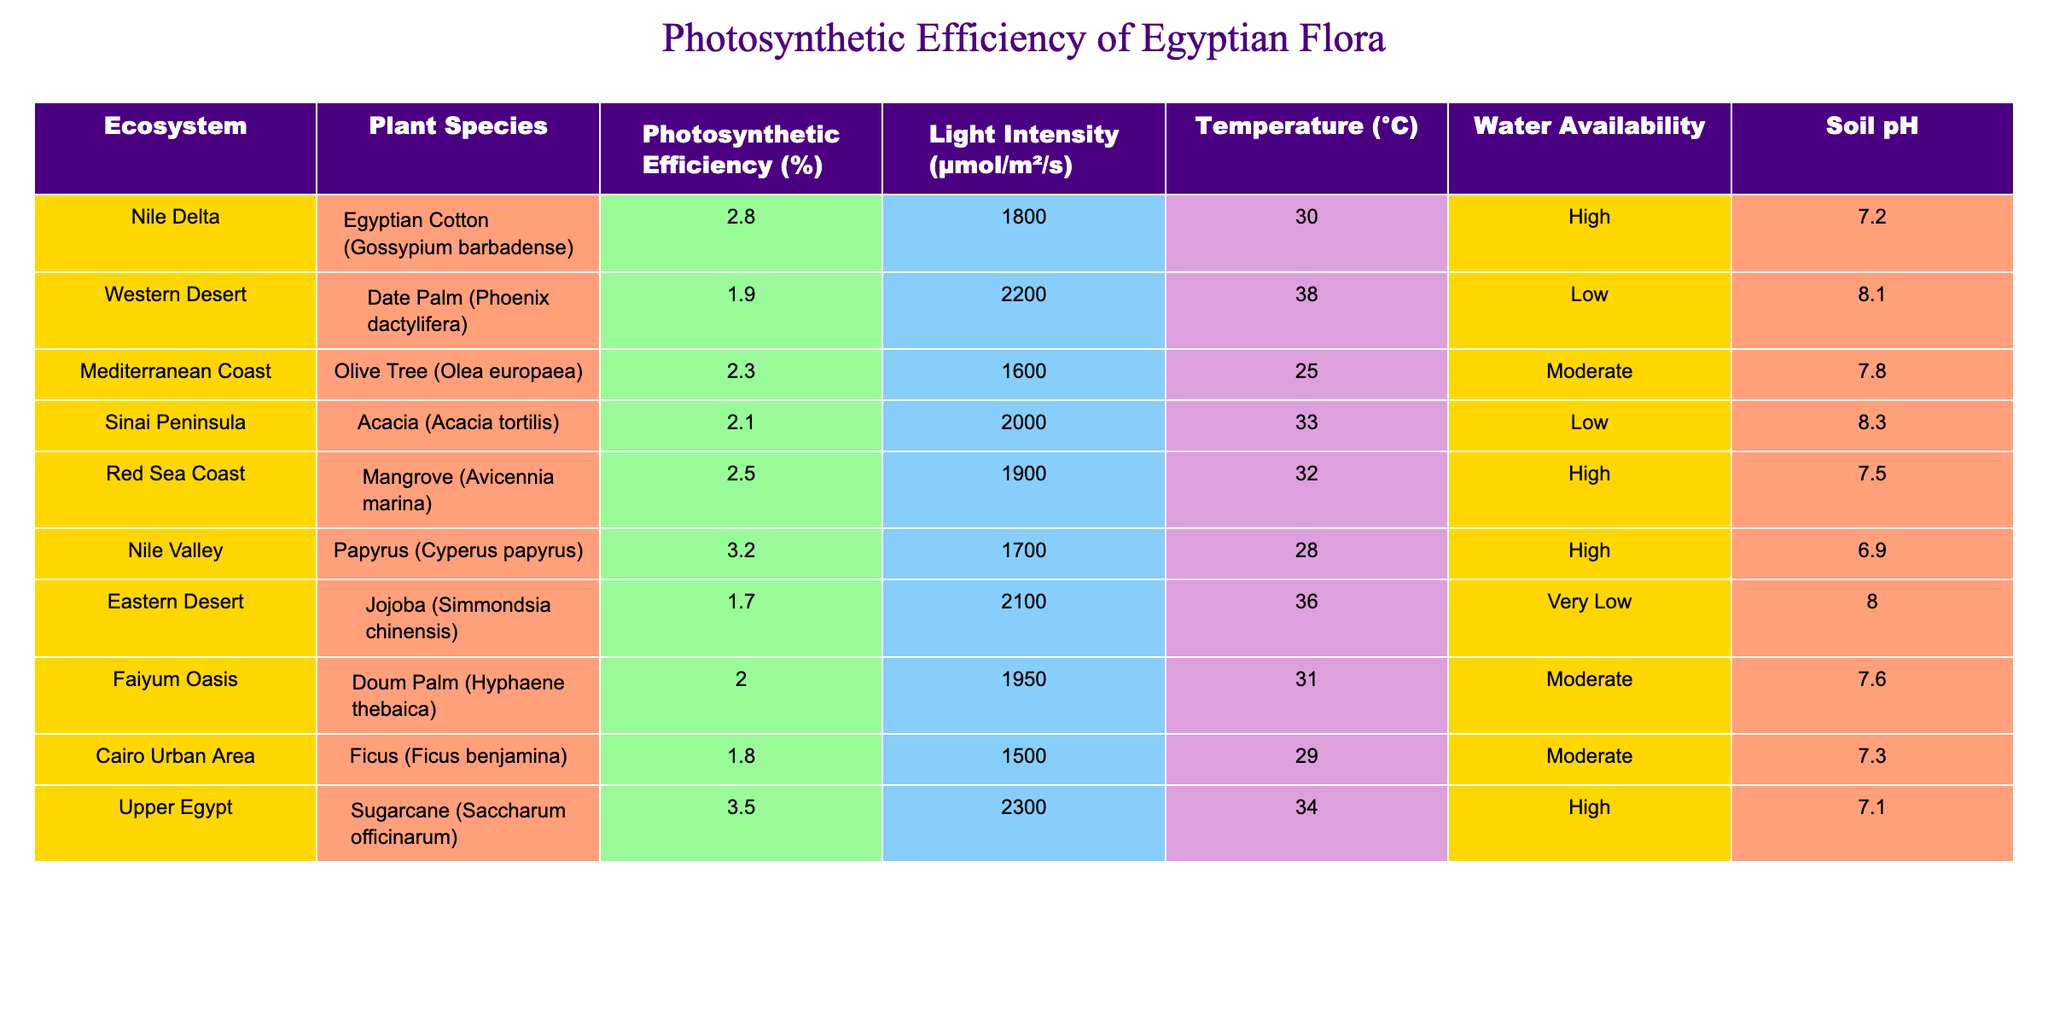What is the photosynthetic efficiency of Nile Delta's Egyptian Cotton? The table shows that the photosynthetic efficiency of Egyptian Cotton (Gossypium barbadense) in the Nile Delta is 2.8%.
Answer: 2.8% Which ecosystem has the highest light intensity? By examining the light intensity column, it can be seen that the Western Desert has the highest light intensity at 2200 μmol/m²/s.
Answer: 2200 μmol/m²/s Is the photosynthetic efficiency of Sugarcane higher than that of the Olive Tree? The table indicates that the photosynthetic efficiency of Sugarcane is 3.5%, while that of the Olive Tree is 2.3%. Since 3.5% is greater than 2.3%, the answer is yes.
Answer: Yes What is the average photosynthetic efficiency across all ecosystems in the table? To calculate the average, sum the photosynthetic efficiencies: 2.8 + 1.9 + 2.3 + 2.1 + 2.5 + 3.2 + 1.7 + 2.0 + 1.8 + 3.5 = 23.0. There are 10 data points, so the average is 23.0 / 10 = 2.3.
Answer: 2.3% Which plant species has the lowest photosynthetic efficiency among those listed? By looking at the photosynthetic efficiency values, Jojoba (Simmondsia chinensis) has the lowest value at 1.7%.
Answer: 1.7% Does the Red Sea Coast have high water availability for its vegetation? According to the table, the Red Sea Coast indicates high water availability for Mangrove (Avicennia marina), which means the answer is yes.
Answer: Yes How does the photosynthetic efficiency of date palms compare to that of papyrus? The photosynthetic efficiency of Date Palm (1.9%) is less than that of Papyrus (3.2%). Therefore, Date Palm is lower in efficiency compared to Papyrus.
Answer: Date Palm is lower Which ecosystem has the lowest soil pH and what species grows there? The Eastern Desert has the lowest soil pH of 8.0, where Jojoba (Simmondsia chinensis) grows.
Answer: Eastern Desert, Jojoba What ecosystems have moderate water availability? The table shows that both the Mediterranean Coast with the Olive Tree and the Faiyum Oasis with Doum Palm have moderate water availability, making them two ecosystems with this characteristic.
Answer: Mediterranean Coast and Faiyum Oasis 